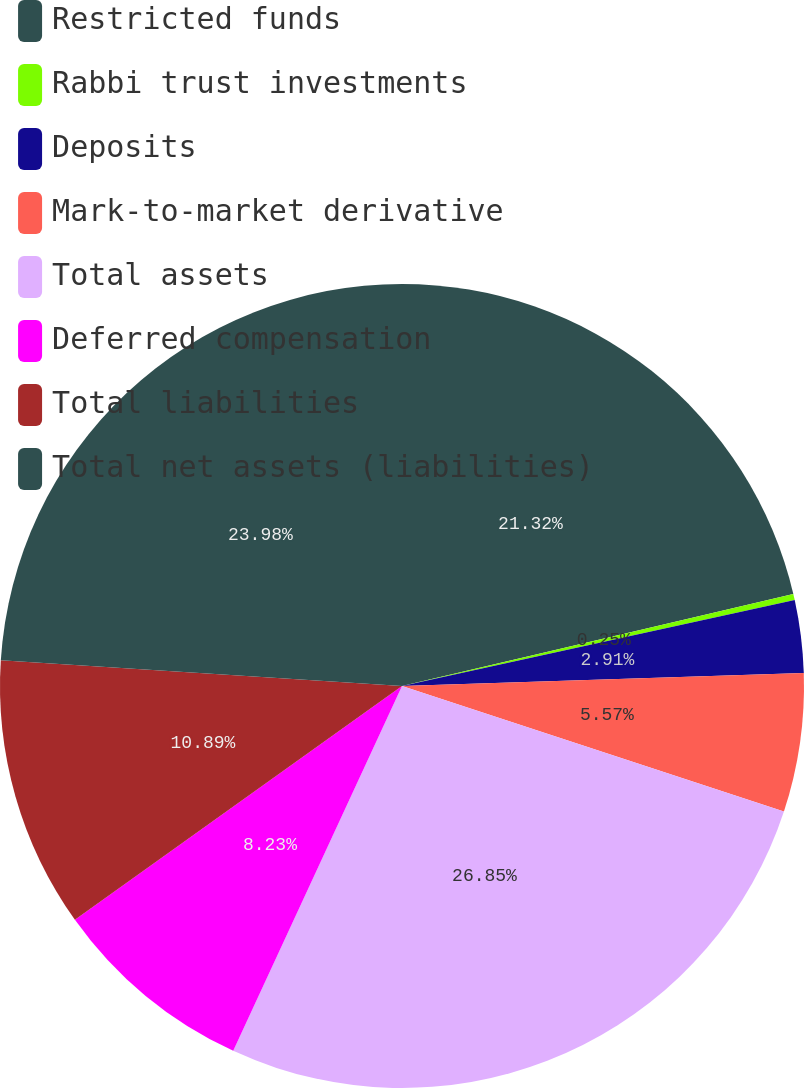<chart> <loc_0><loc_0><loc_500><loc_500><pie_chart><fcel>Restricted funds<fcel>Rabbi trust investments<fcel>Deposits<fcel>Mark-to-market derivative<fcel>Total assets<fcel>Deferred compensation<fcel>Total liabilities<fcel>Total net assets (liabilities)<nl><fcel>21.32%<fcel>0.25%<fcel>2.91%<fcel>5.57%<fcel>26.84%<fcel>8.23%<fcel>10.89%<fcel>23.98%<nl></chart> 